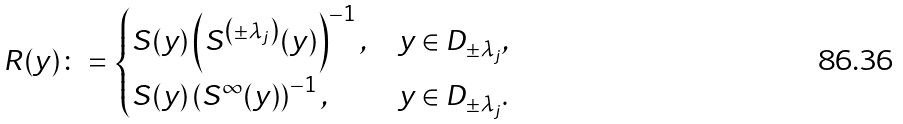Convert formula to latex. <formula><loc_0><loc_0><loc_500><loc_500>R ( y ) \colon = \begin{cases} S ( y ) \left ( S ^ { \left ( \pm \lambda _ { j } \right ) } ( y ) \right ) ^ { - 1 } , & y \in D _ { \pm \lambda _ { j } } , \\ S ( y ) \left ( S ^ { \infty } ( y ) \right ) ^ { - 1 } , & y \in D _ { \pm \lambda _ { j } } . \end{cases}</formula> 